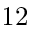Convert formula to latex. <formula><loc_0><loc_0><loc_500><loc_500>1 2</formula> 